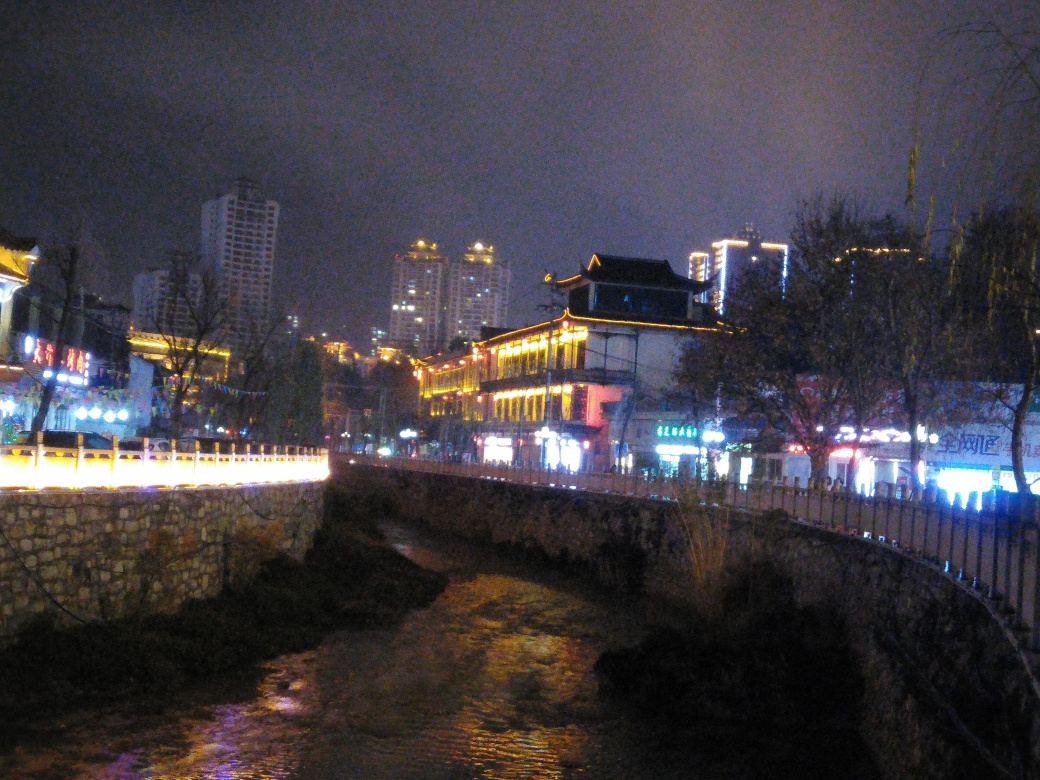What is the clarity of the main subject, an ancient building?
A. The clarity of the main subject is poor.
B. The clarity of the main subject is exceptional.
C. The clarity of the main subject is decent.
D. The clarity of the main subject is excellent.
Answer with the option's letter from the given choices directly. The clarity of the main subject, the ancient building, is best described as 'decent.' While the image is not sharply focused, the building's outline and some architectural details are distinguishable. Ambient lighting and a dynamic range of colors from surrounding lights contribute to the visual appeal, despite the apparent noise and graininess that tends to occur in low-light photography. 